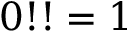Convert formula to latex. <formula><loc_0><loc_0><loc_500><loc_500>0 ! ! = 1</formula> 